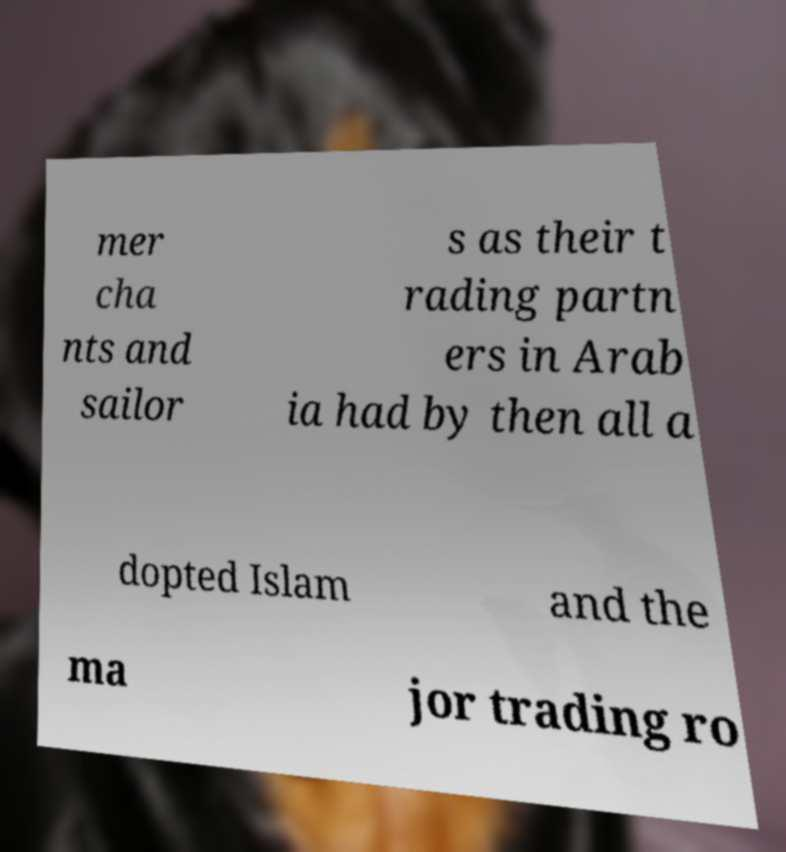There's text embedded in this image that I need extracted. Can you transcribe it verbatim? mer cha nts and sailor s as their t rading partn ers in Arab ia had by then all a dopted Islam and the ma jor trading ro 